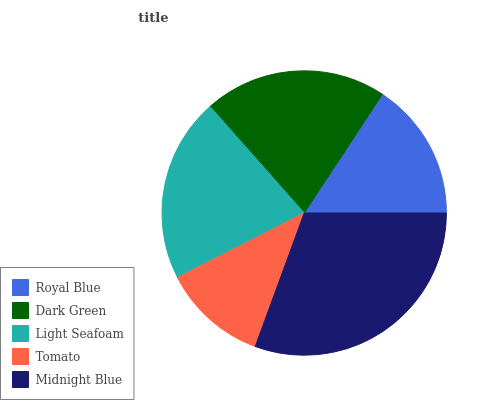Is Tomato the minimum?
Answer yes or no. Yes. Is Midnight Blue the maximum?
Answer yes or no. Yes. Is Dark Green the minimum?
Answer yes or no. No. Is Dark Green the maximum?
Answer yes or no. No. Is Dark Green greater than Royal Blue?
Answer yes or no. Yes. Is Royal Blue less than Dark Green?
Answer yes or no. Yes. Is Royal Blue greater than Dark Green?
Answer yes or no. No. Is Dark Green less than Royal Blue?
Answer yes or no. No. Is Dark Green the high median?
Answer yes or no. Yes. Is Dark Green the low median?
Answer yes or no. Yes. Is Royal Blue the high median?
Answer yes or no. No. Is Tomato the low median?
Answer yes or no. No. 